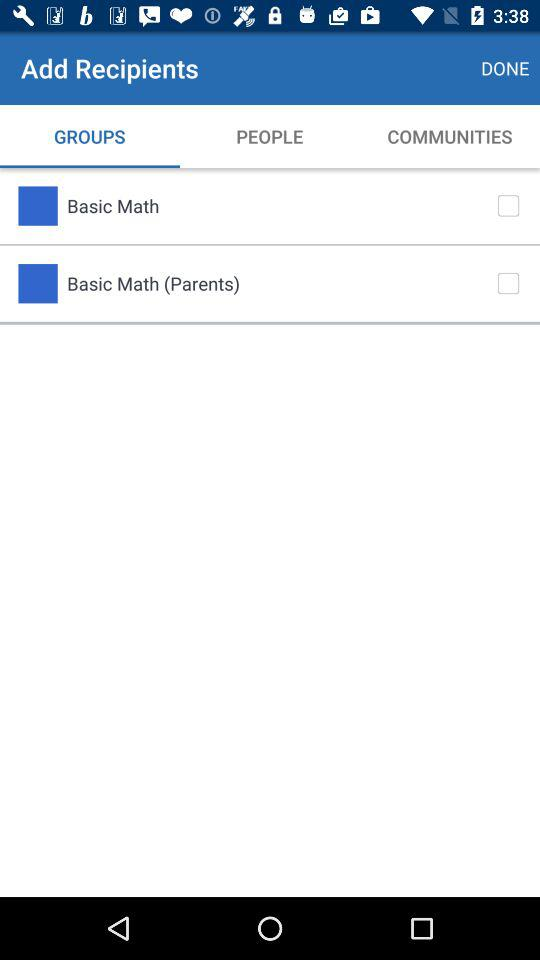What are the names of the groups? The names of the groups are "Basic Math" and "Basic Math (Parents)". 